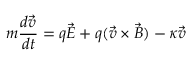Convert formula to latex. <formula><loc_0><loc_0><loc_500><loc_500>m \frac { d \vec { v } } { d t } = q \vec { E } + q ( \vec { v } \times \vec { B } ) - \kappa \vec { v }</formula> 